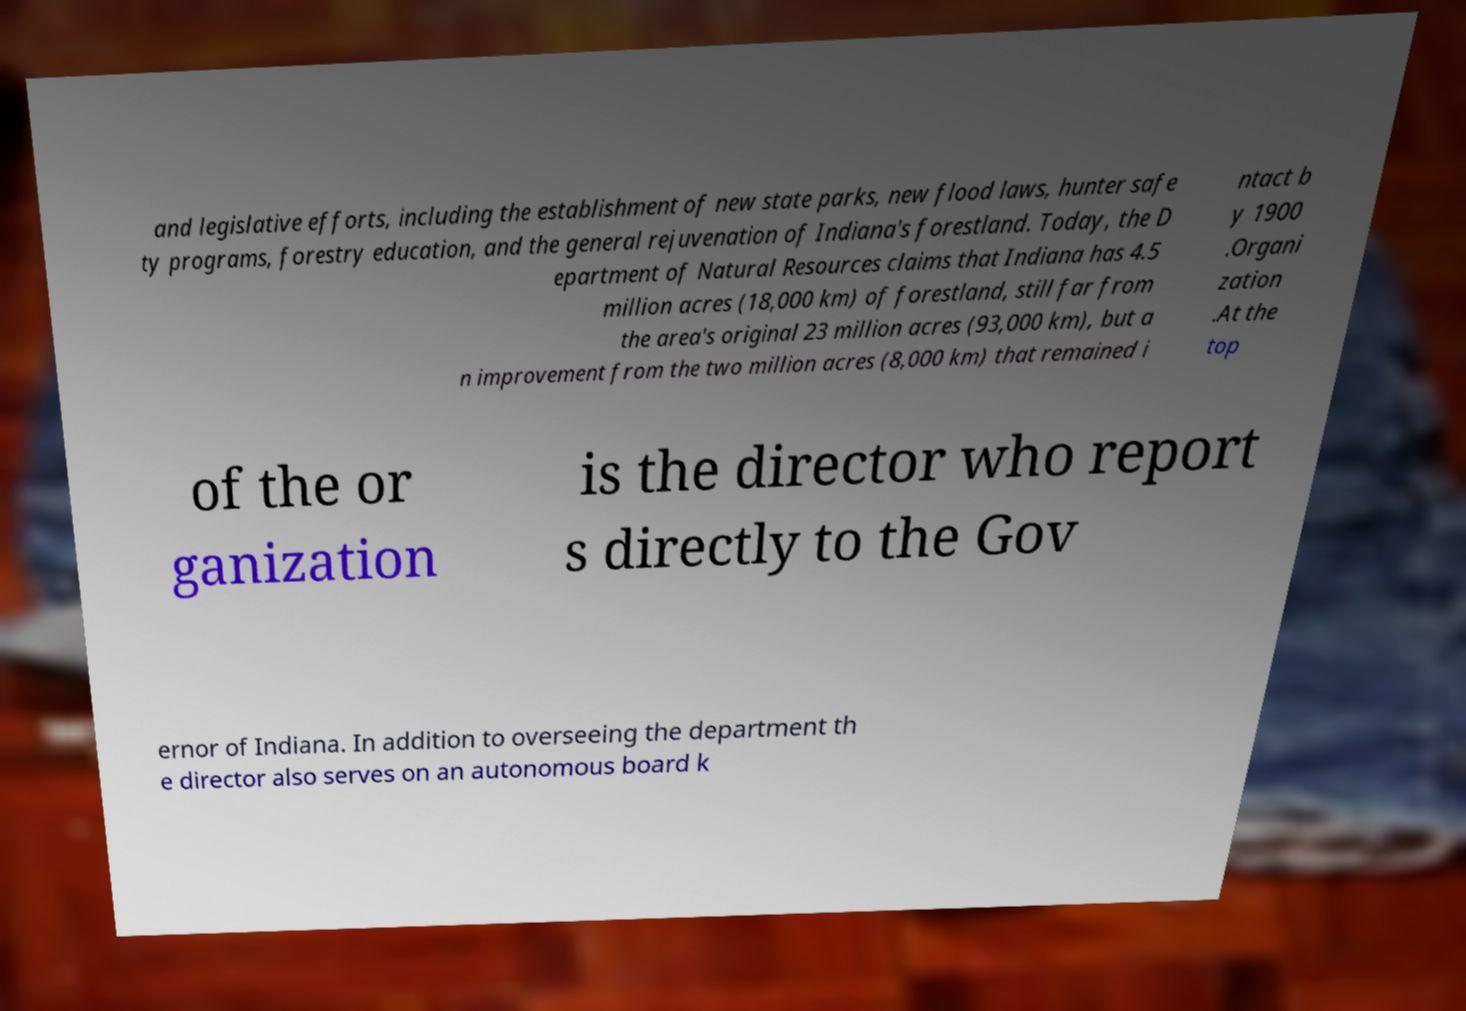For documentation purposes, I need the text within this image transcribed. Could you provide that? and legislative efforts, including the establishment of new state parks, new flood laws, hunter safe ty programs, forestry education, and the general rejuvenation of Indiana's forestland. Today, the D epartment of Natural Resources claims that Indiana has 4.5 million acres (18,000 km) of forestland, still far from the area's original 23 million acres (93,000 km), but a n improvement from the two million acres (8,000 km) that remained i ntact b y 1900 .Organi zation .At the top of the or ganization is the director who report s directly to the Gov ernor of Indiana. In addition to overseeing the department th e director also serves on an autonomous board k 